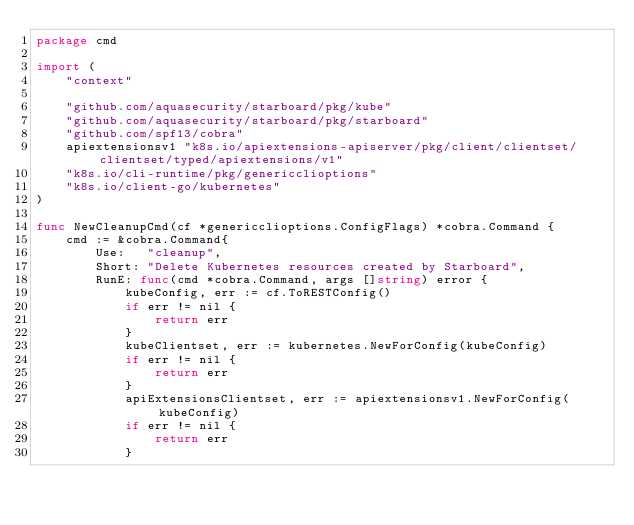<code> <loc_0><loc_0><loc_500><loc_500><_Go_>package cmd

import (
	"context"

	"github.com/aquasecurity/starboard/pkg/kube"
	"github.com/aquasecurity/starboard/pkg/starboard"
	"github.com/spf13/cobra"
	apiextensionsv1 "k8s.io/apiextensions-apiserver/pkg/client/clientset/clientset/typed/apiextensions/v1"
	"k8s.io/cli-runtime/pkg/genericclioptions"
	"k8s.io/client-go/kubernetes"
)

func NewCleanupCmd(cf *genericclioptions.ConfigFlags) *cobra.Command {
	cmd := &cobra.Command{
		Use:   "cleanup",
		Short: "Delete Kubernetes resources created by Starboard",
		RunE: func(cmd *cobra.Command, args []string) error {
			kubeConfig, err := cf.ToRESTConfig()
			if err != nil {
				return err
			}
			kubeClientset, err := kubernetes.NewForConfig(kubeConfig)
			if err != nil {
				return err
			}
			apiExtensionsClientset, err := apiextensionsv1.NewForConfig(kubeConfig)
			if err != nil {
				return err
			}</code> 